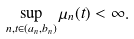<formula> <loc_0><loc_0><loc_500><loc_500>\sup _ { n , t \in ( a _ { n } , b _ { n } ) } \mu _ { n } ( t ) < \infty .</formula> 